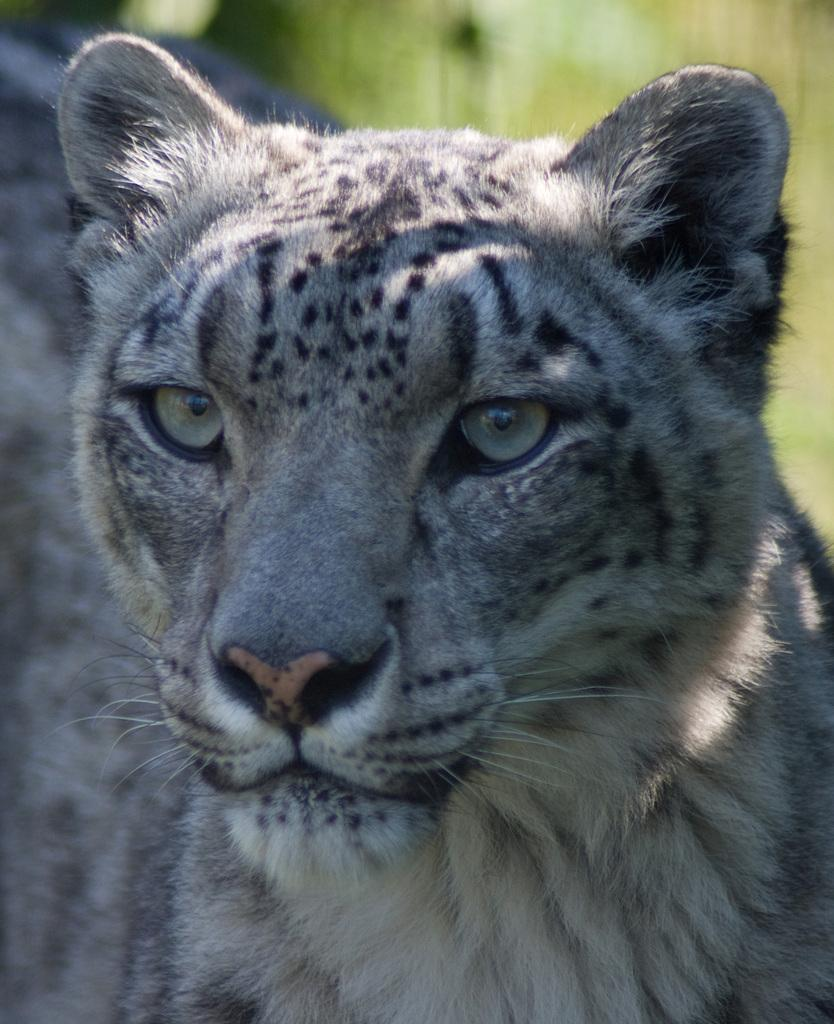What type of animal is in the image? There is a snow leopard in the image. Can you describe the appearance of the snow leopard? The snow leopard has a white and gray coat with black spots and a long tail. What is the natural habitat of the snow leopard? Snow leopards are typically found in the mountain ranges of Central Asia. What type of earrings is the doctor wearing in the image? There is no doctor or earrings present in the image; it features a snow leopard. What type of book is the writer holding in the image? There is no writer or book present in the image; it features a snow leopard. 